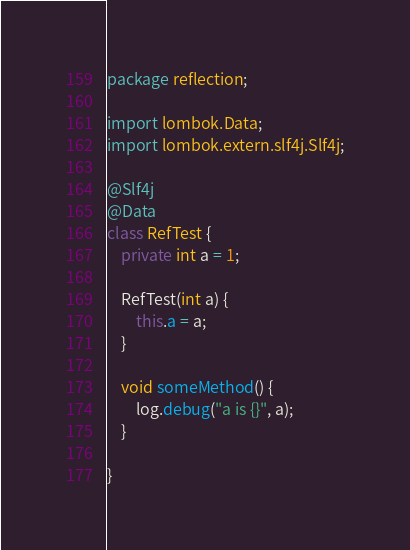<code> <loc_0><loc_0><loc_500><loc_500><_Java_>package reflection;

import lombok.Data;
import lombok.extern.slf4j.Slf4j;

@Slf4j
@Data
class RefTest {
    private int a = 1;

    RefTest(int a) {
        this.a = a;
    }

    void someMethod() {
        log.debug("a is {}", a);
    }

}
</code> 